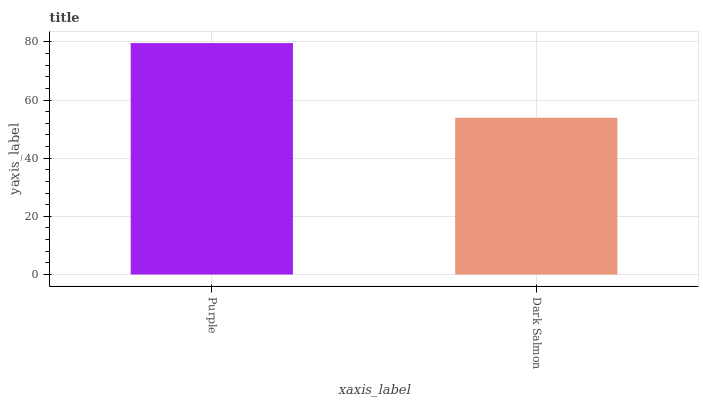Is Dark Salmon the minimum?
Answer yes or no. Yes. Is Purple the maximum?
Answer yes or no. Yes. Is Dark Salmon the maximum?
Answer yes or no. No. Is Purple greater than Dark Salmon?
Answer yes or no. Yes. Is Dark Salmon less than Purple?
Answer yes or no. Yes. Is Dark Salmon greater than Purple?
Answer yes or no. No. Is Purple less than Dark Salmon?
Answer yes or no. No. Is Purple the high median?
Answer yes or no. Yes. Is Dark Salmon the low median?
Answer yes or no. Yes. Is Dark Salmon the high median?
Answer yes or no. No. Is Purple the low median?
Answer yes or no. No. 